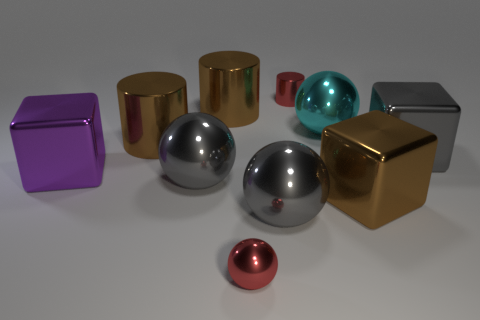The cyan thing that is made of the same material as the purple cube is what shape?
Provide a succinct answer. Sphere. How many objects are behind the tiny sphere and left of the large brown block?
Ensure brevity in your answer.  7. Are there any cyan metal objects left of the large cyan sphere?
Make the answer very short. No. There is a large brown object that is in front of the large gray shiny cube; is its shape the same as the big thing that is behind the cyan ball?
Ensure brevity in your answer.  No. What number of objects are either big purple shiny things or gray metallic objects that are to the right of the brown cube?
Provide a succinct answer. 2. How many other objects are the same shape as the cyan shiny thing?
Offer a very short reply. 3. Is the ball behind the large purple block made of the same material as the tiny sphere?
Keep it short and to the point. Yes. How many things are gray metallic spheres or brown shiny cylinders?
Give a very brief answer. 4. What is the size of the red metallic object that is the same shape as the large cyan metallic thing?
Make the answer very short. Small. What is the size of the gray metallic block?
Offer a terse response. Large. 